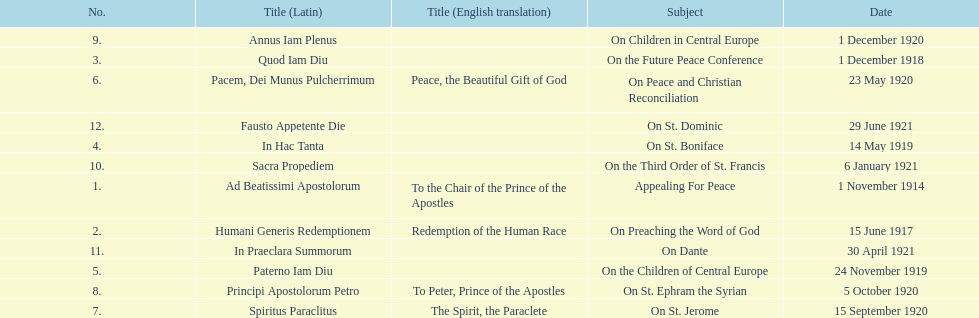Could you parse the entire table as a dict? {'header': ['No.', 'Title (Latin)', 'Title (English translation)', 'Subject', 'Date'], 'rows': [['9.', 'Annus Iam Plenus', '', 'On Children in Central Europe', '1 December 1920'], ['3.', 'Quod Iam Diu', '', 'On the Future Peace Conference', '1 December 1918'], ['6.', 'Pacem, Dei Munus Pulcherrimum', 'Peace, the Beautiful Gift of God', 'On Peace and Christian Reconciliation', '23 May 1920'], ['12.', 'Fausto Appetente Die', '', 'On St. Dominic', '29 June 1921'], ['4.', 'In Hac Tanta', '', 'On St. Boniface', '14 May 1919'], ['10.', 'Sacra Propediem', '', 'On the Third Order of St. Francis', '6 January 1921'], ['1.', 'Ad Beatissimi Apostolorum', 'To the Chair of the Prince of the Apostles', 'Appealing For Peace', '1 November 1914'], ['2.', 'Humani Generis Redemptionem', 'Redemption of the Human Race', 'On Preaching the Word of God', '15 June 1917'], ['11.', 'In Praeclara Summorum', '', 'On Dante', '30 April 1921'], ['5.', 'Paterno Iam Diu', '', 'On the Children of Central Europe', '24 November 1919'], ['8.', 'Principi Apostolorum Petro', 'To Peter, Prince of the Apostles', 'On St. Ephram the Syrian', '5 October 1920'], ['7.', 'Spiritus Paraclitus', 'The Spirit, the Paraclete', 'On St. Jerome', '15 September 1920']]} How long after quod iam diu was paterno iam diu issued? 11 months. 